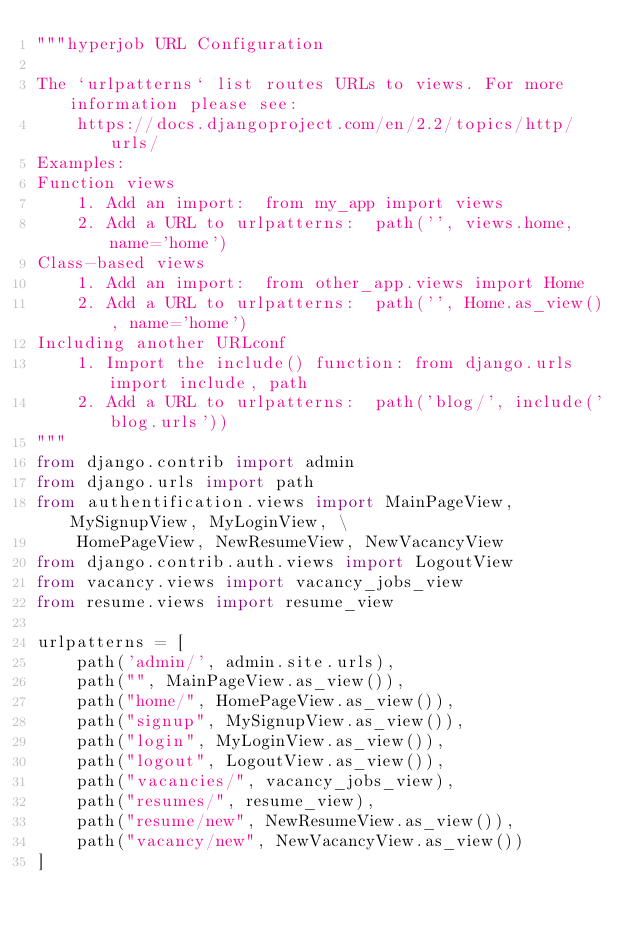<code> <loc_0><loc_0><loc_500><loc_500><_Python_>"""hyperjob URL Configuration

The `urlpatterns` list routes URLs to views. For more information please see:
    https://docs.djangoproject.com/en/2.2/topics/http/urls/
Examples:
Function views
    1. Add an import:  from my_app import views
    2. Add a URL to urlpatterns:  path('', views.home, name='home')
Class-based views
    1. Add an import:  from other_app.views import Home
    2. Add a URL to urlpatterns:  path('', Home.as_view(), name='home')
Including another URLconf
    1. Import the include() function: from django.urls import include, path
    2. Add a URL to urlpatterns:  path('blog/', include('blog.urls'))
"""
from django.contrib import admin
from django.urls import path
from authentification.views import MainPageView, MySignupView, MyLoginView, \
    HomePageView, NewResumeView, NewVacancyView
from django.contrib.auth.views import LogoutView
from vacancy.views import vacancy_jobs_view
from resume.views import resume_view

urlpatterns = [
    path('admin/', admin.site.urls),
    path("", MainPageView.as_view()),
    path("home/", HomePageView.as_view()),
    path("signup", MySignupView.as_view()),
    path("login", MyLoginView.as_view()),
    path("logout", LogoutView.as_view()),
    path("vacancies/", vacancy_jobs_view),
    path("resumes/", resume_view),
    path("resume/new", NewResumeView.as_view()),
    path("vacancy/new", NewVacancyView.as_view())
]
</code> 